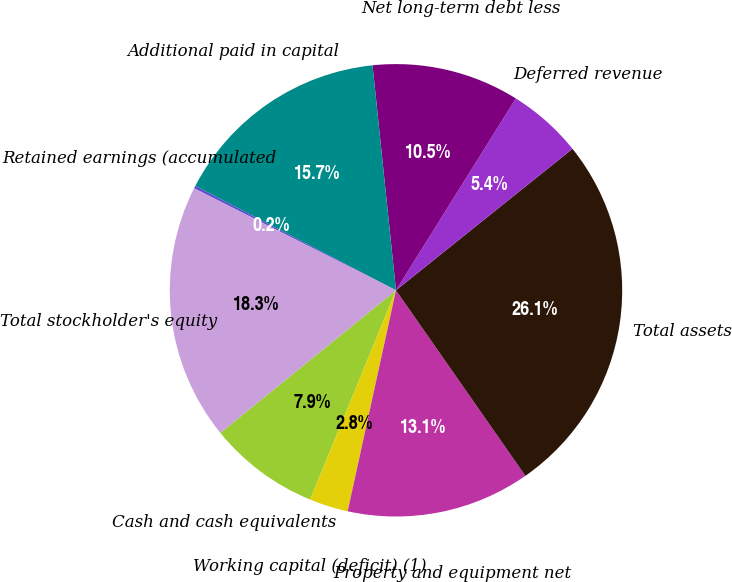<chart> <loc_0><loc_0><loc_500><loc_500><pie_chart><fcel>Cash and cash equivalents<fcel>Working capital (deficit) (1)<fcel>Property and equipment net<fcel>Total assets<fcel>Deferred revenue<fcel>Net long-term debt less<fcel>Additional paid in capital<fcel>Retained earnings (accumulated<fcel>Total stockholder's equity<nl><fcel>7.95%<fcel>2.77%<fcel>13.12%<fcel>26.06%<fcel>5.36%<fcel>10.54%<fcel>15.71%<fcel>0.19%<fcel>18.3%<nl></chart> 